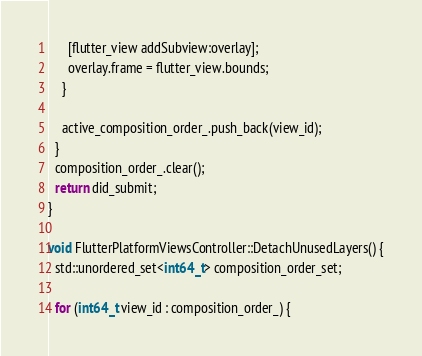<code> <loc_0><loc_0><loc_500><loc_500><_ObjectiveC_>      [flutter_view addSubview:overlay];
      overlay.frame = flutter_view.bounds;
    }

    active_composition_order_.push_back(view_id);
  }
  composition_order_.clear();
  return did_submit;
}

void FlutterPlatformViewsController::DetachUnusedLayers() {
  std::unordered_set<int64_t> composition_order_set;

  for (int64_t view_id : composition_order_) {</code> 